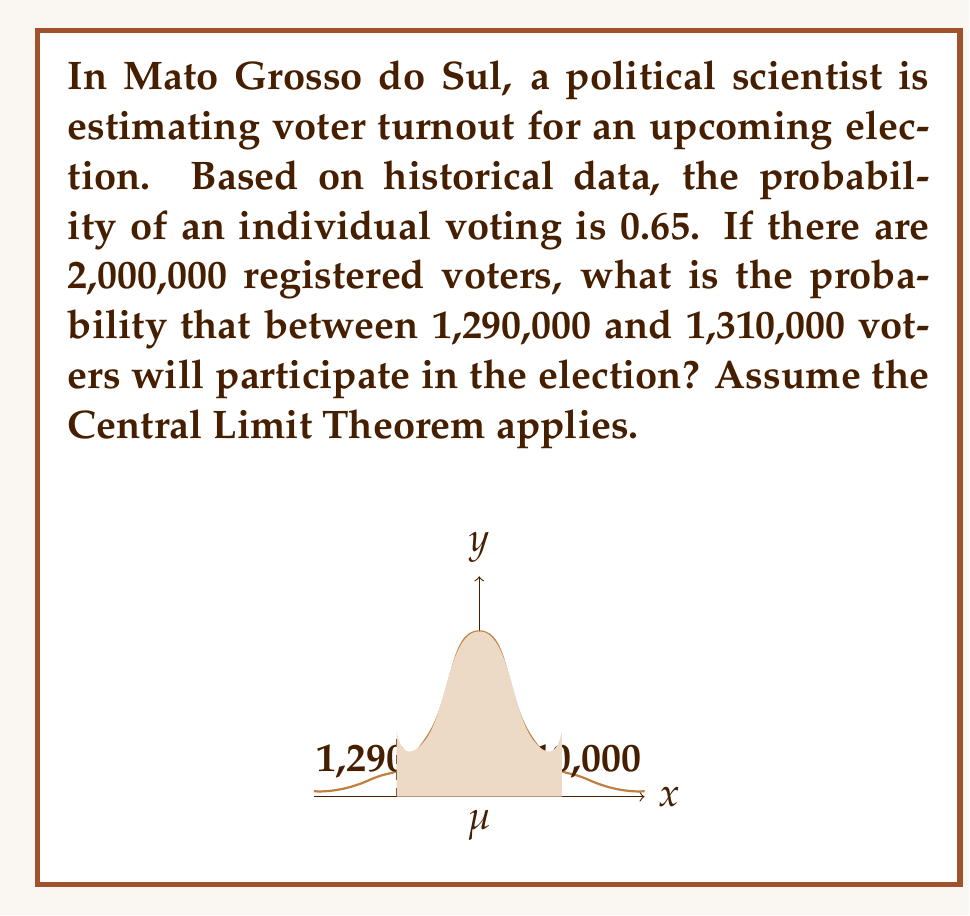Can you solve this math problem? Let's approach this step-by-step:

1) First, we need to identify the parameters:
   - $n$ (number of trials) = 2,000,000
   - $p$ (probability of success) = 0.65
   - $q$ (probability of failure) = 1 - 0.65 = 0.35

2) Calculate the mean (μ) of the binomial distribution:
   $$μ = np = 2,000,000 * 0.65 = 1,300,000$$

3) Calculate the standard deviation (σ) of the binomial distribution:
   $$σ = \sqrt{npq} = \sqrt{2,000,000 * 0.65 * 0.35} = 671.96$$

4) As $n$ is large, we can use the normal approximation to the binomial distribution.

5) Standardize the given range to z-scores:
   $$z_1 = \frac{1,290,000 - 1,300,000}{671.96} = -14.88$$
   $$z_2 = \frac{1,310,000 - 1,300,000}{671.96} = 14.88$$

6) The probability is the area between these z-scores on a standard normal distribution.

7) Using a standard normal table or calculator:
   $$P(-14.88 < Z < 14.88) = P(Z < 14.88) - P(Z < -14.88)$$
   $$= 1 - P(Z < -14.88) - P(Z < -14.88)$$
   $$= 1 - 2P(Z < -14.88)$$
   $$= 1 - 2(0) = 1$$

The probability is essentially 1, as the range is about 22 standard deviations wide.
Answer: 1 